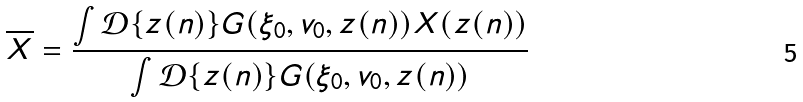Convert formula to latex. <formula><loc_0><loc_0><loc_500><loc_500>\overline { X } = \frac { \int \mathcal { D } \{ z ( n ) \} G ( \xi _ { 0 } , v _ { 0 } , z ( n ) ) X ( z ( n ) ) } { \int \mathcal { D } \{ z ( n ) \} G ( \xi _ { 0 } , v _ { 0 } , z ( n ) ) }</formula> 